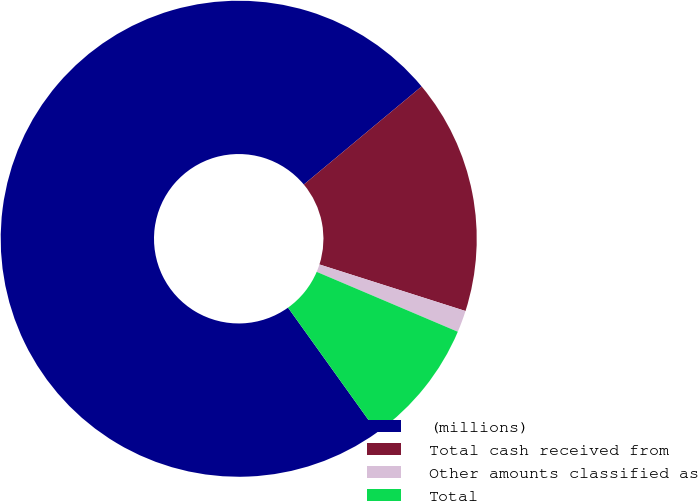Convert chart to OTSL. <chart><loc_0><loc_0><loc_500><loc_500><pie_chart><fcel>(millions)<fcel>Total cash received from<fcel>Other amounts classified as<fcel>Total<nl><fcel>73.84%<fcel>15.96%<fcel>1.48%<fcel>8.72%<nl></chart> 